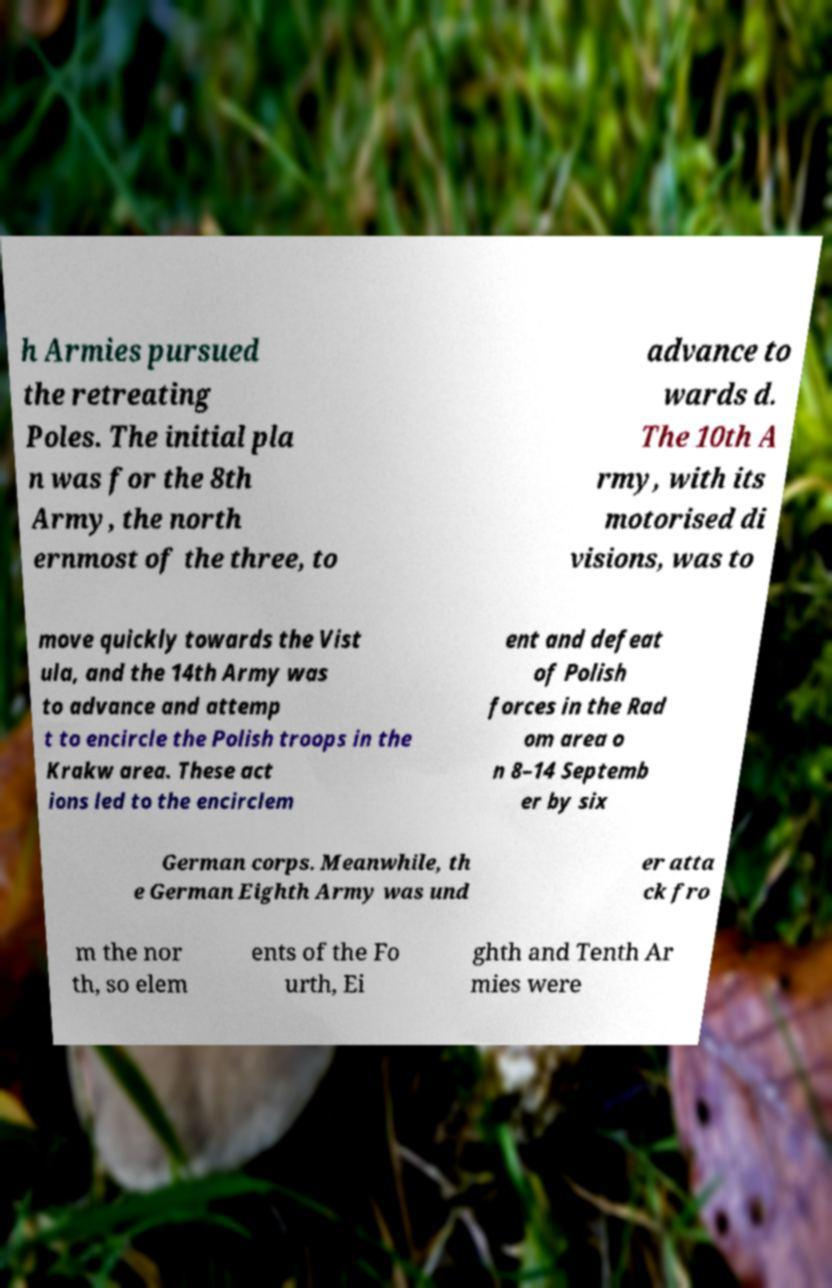Please identify and transcribe the text found in this image. h Armies pursued the retreating Poles. The initial pla n was for the 8th Army, the north ernmost of the three, to advance to wards d. The 10th A rmy, with its motorised di visions, was to move quickly towards the Vist ula, and the 14th Army was to advance and attemp t to encircle the Polish troops in the Krakw area. These act ions led to the encirclem ent and defeat of Polish forces in the Rad om area o n 8–14 Septemb er by six German corps. Meanwhile, th e German Eighth Army was und er atta ck fro m the nor th, so elem ents of the Fo urth, Ei ghth and Tenth Ar mies were 